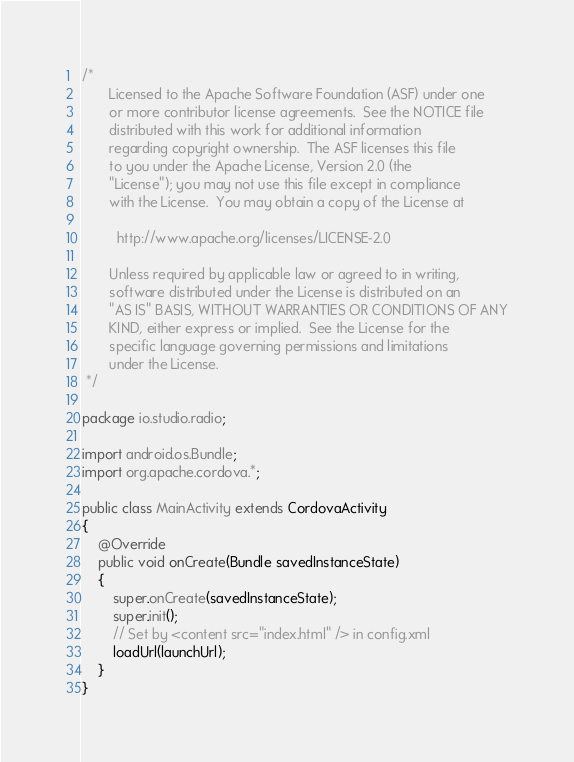Convert code to text. <code><loc_0><loc_0><loc_500><loc_500><_Java_>/*
       Licensed to the Apache Software Foundation (ASF) under one
       or more contributor license agreements.  See the NOTICE file
       distributed with this work for additional information
       regarding copyright ownership.  The ASF licenses this file
       to you under the Apache License, Version 2.0 (the
       "License"); you may not use this file except in compliance
       with the License.  You may obtain a copy of the License at

         http://www.apache.org/licenses/LICENSE-2.0

       Unless required by applicable law or agreed to in writing,
       software distributed under the License is distributed on an
       "AS IS" BASIS, WITHOUT WARRANTIES OR CONDITIONS OF ANY
       KIND, either express or implied.  See the License for the
       specific language governing permissions and limitations
       under the License.
 */

package io.studio.radio;

import android.os.Bundle;
import org.apache.cordova.*;

public class MainActivity extends CordovaActivity
{
    @Override
    public void onCreate(Bundle savedInstanceState)
    {
        super.onCreate(savedInstanceState);
        super.init();
        // Set by <content src="index.html" /> in config.xml
        loadUrl(launchUrl);
    }
}
</code> 